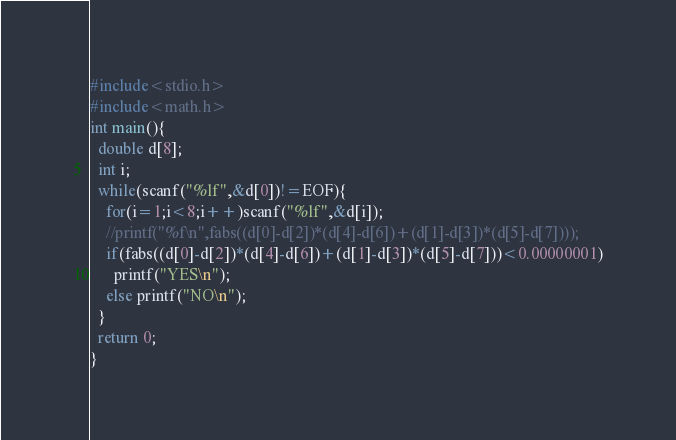<code> <loc_0><loc_0><loc_500><loc_500><_C_>#include<stdio.h>
#include<math.h>
int main(){
  double d[8];
  int i;
  while(scanf("%lf",&d[0])!=EOF){
    for(i=1;i<8;i++)scanf("%lf",&d[i]);
    //printf("%f\n",fabs((d[0]-d[2])*(d[4]-d[6])+(d[1]-d[3])*(d[5]-d[7])));
    if(fabs((d[0]-d[2])*(d[4]-d[6])+(d[1]-d[3])*(d[5]-d[7]))<0.00000001)
      printf("YES\n");
    else printf("NO\n");
  }
  return 0;
}</code> 